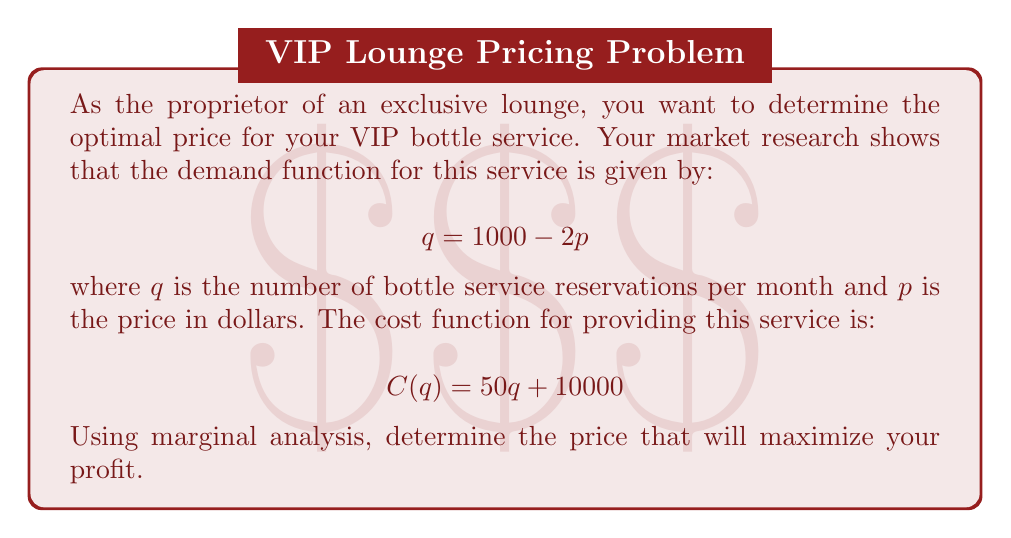Provide a solution to this math problem. To solve this problem, we'll follow these steps:

1) First, let's express the revenue function in terms of $p$:
   $$R(p) = p \cdot q = p(1000 - 2p) = 1000p - 2p^2$$

2) Now, we need to express the cost function in terms of $p$:
   $$C(p) = 50(1000 - 2p) + 10000 = 60000 - 100p$$

3) The profit function is revenue minus cost:
   $$\Pi(p) = R(p) - C(p) = (1000p - 2p^2) - (60000 - 100p)$$
   $$\Pi(p) = 1100p - 2p^2 - 60000$$

4) To maximize profit, we find where the derivative of the profit function equals zero:
   $$\frac{d\Pi}{dp} = 1100 - 4p$$
   $$1100 - 4p = 0$$
   $$4p = 1100$$
   $$p = 275$$

5) To confirm this is a maximum, we check the second derivative:
   $$\frac{d^2\Pi}{dp^2} = -4 < 0$$
   This confirms that $p = 275$ gives a maximum profit.

6) At this price, the quantity sold will be:
   $$q = 1000 - 2(275) = 450$$
Answer: $275 per bottle 